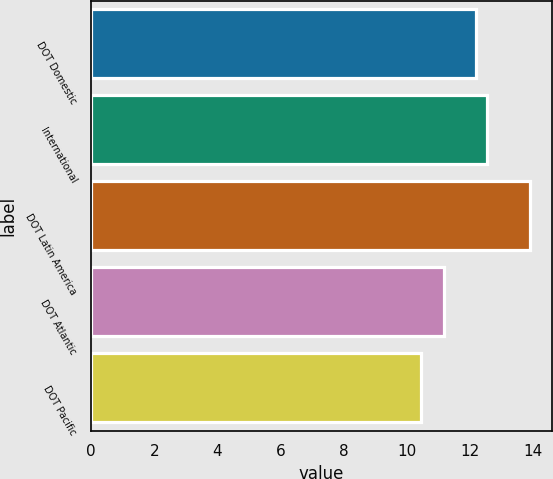Convert chart. <chart><loc_0><loc_0><loc_500><loc_500><bar_chart><fcel>DOT Domestic<fcel>International<fcel>DOT Latin America<fcel>DOT Atlantic<fcel>DOT Pacific<nl><fcel>12.18<fcel>12.52<fcel>13.89<fcel>11.17<fcel>10.45<nl></chart> 